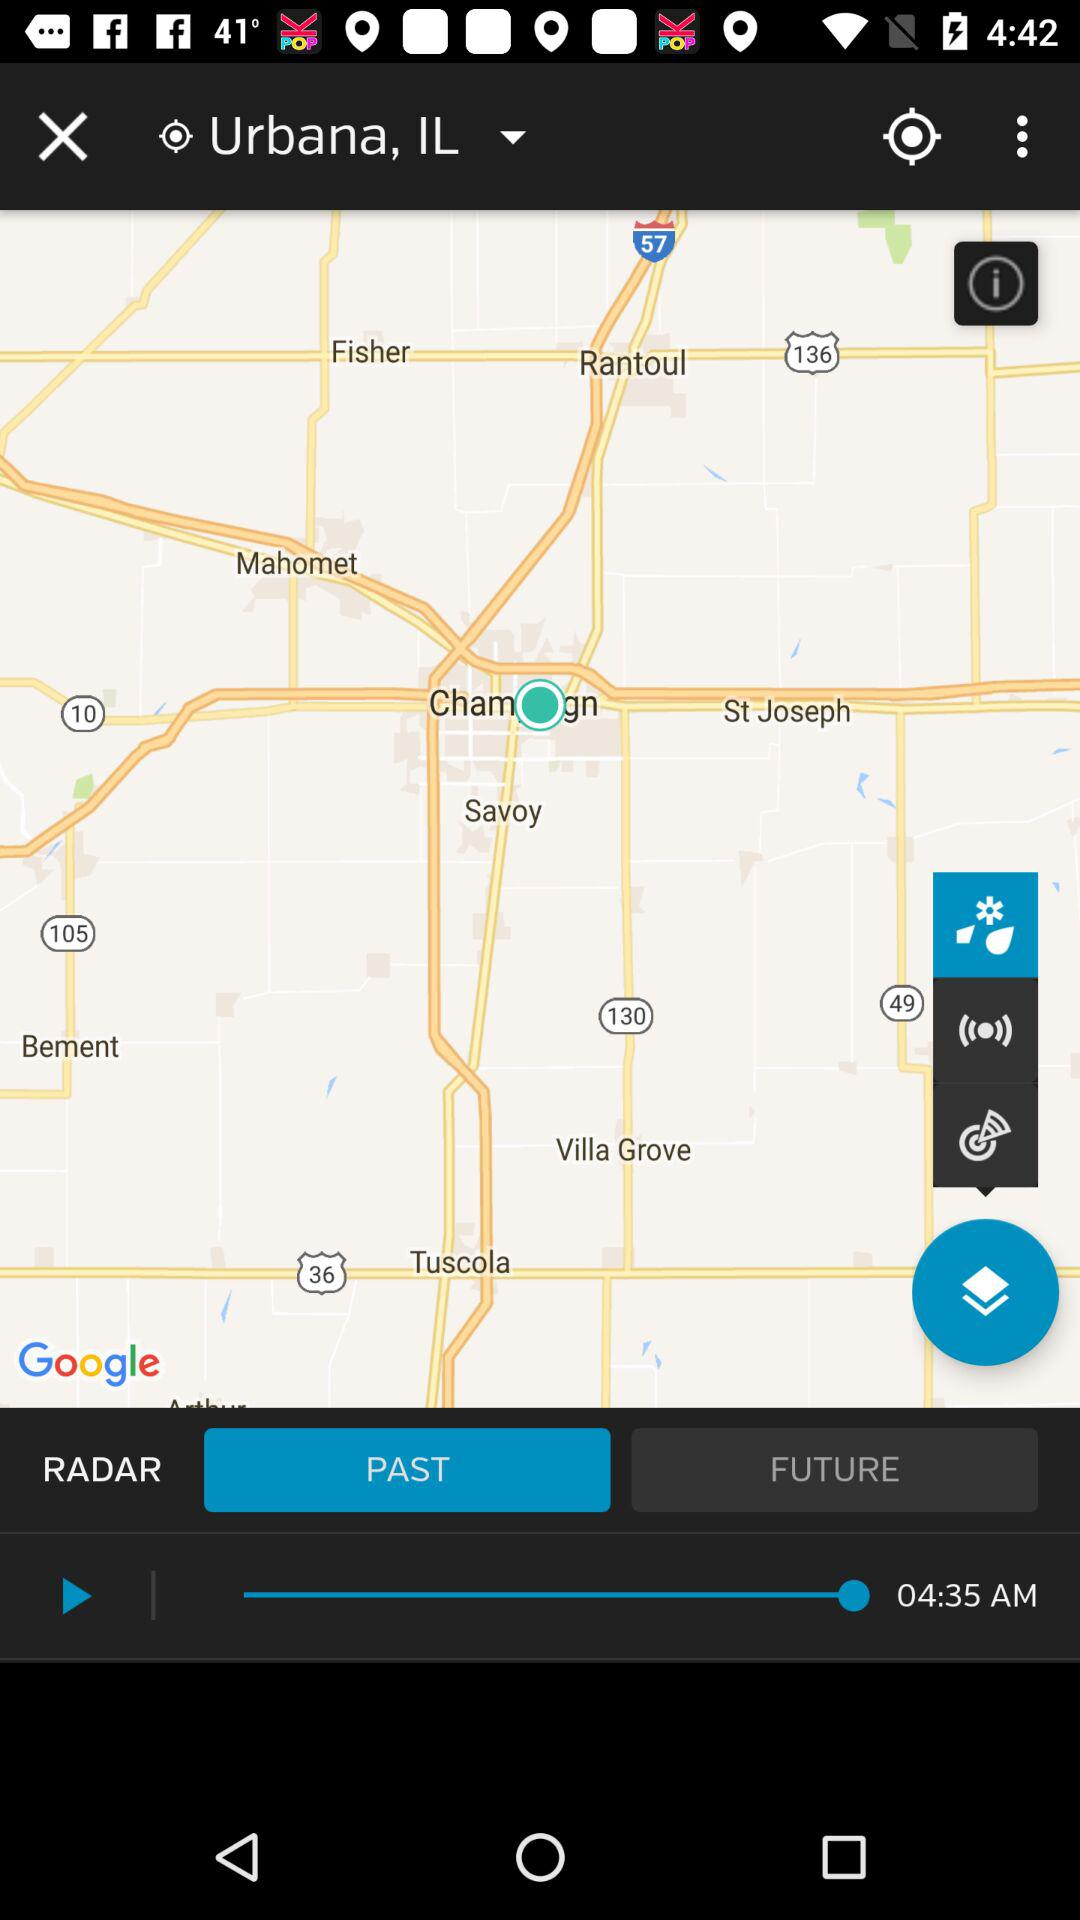Which button is currently highlighted? The currently highlighted button is "PAST". 